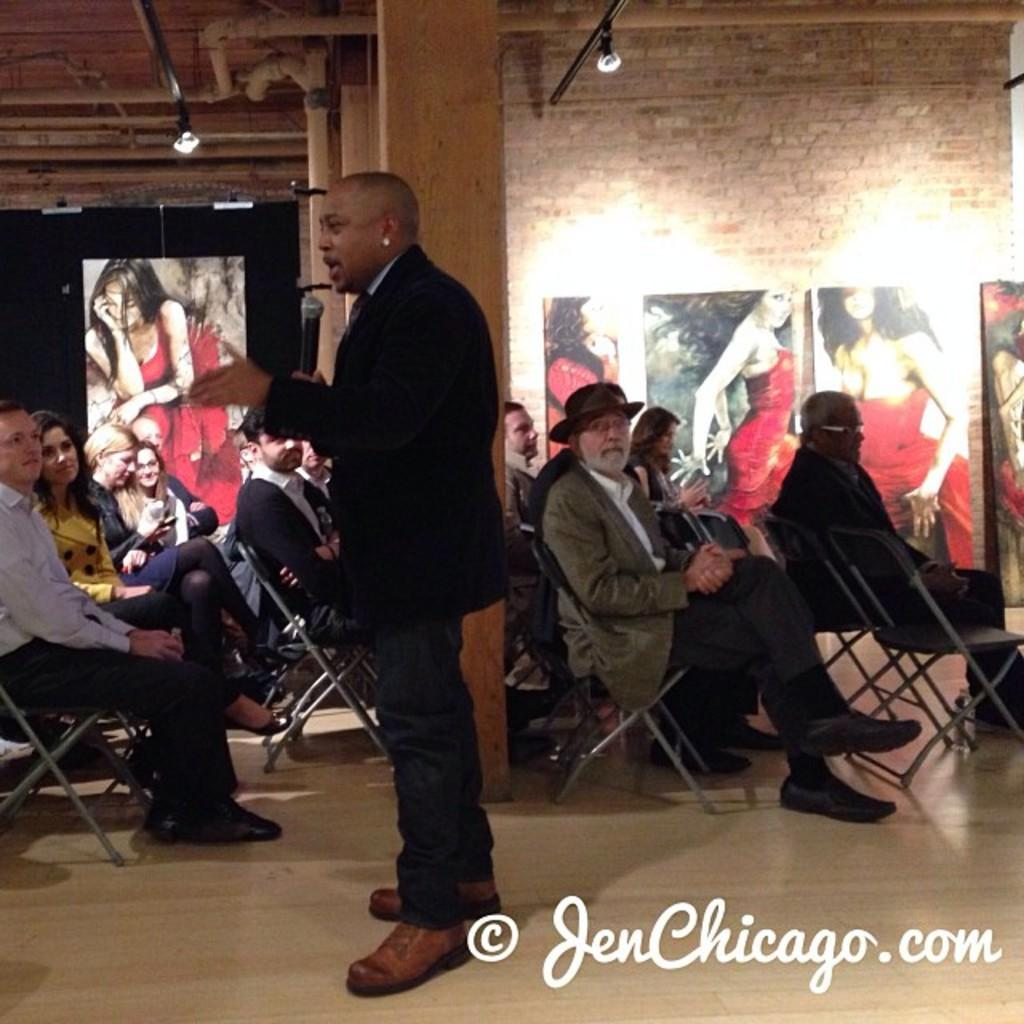What is the person in the image doing? The person is standing and speaking in a mic. What are the other people in the image doing? The other people are seated on chairs. What can be seen on the wall in the image? There are posters on the wall. What type of tax is being discussed in the image? There is no mention of tax in the image; it features a person speaking in a mic and people seated on chairs with posters on the wall. How many ducks are visible in the image? There are no ducks present in the image. 